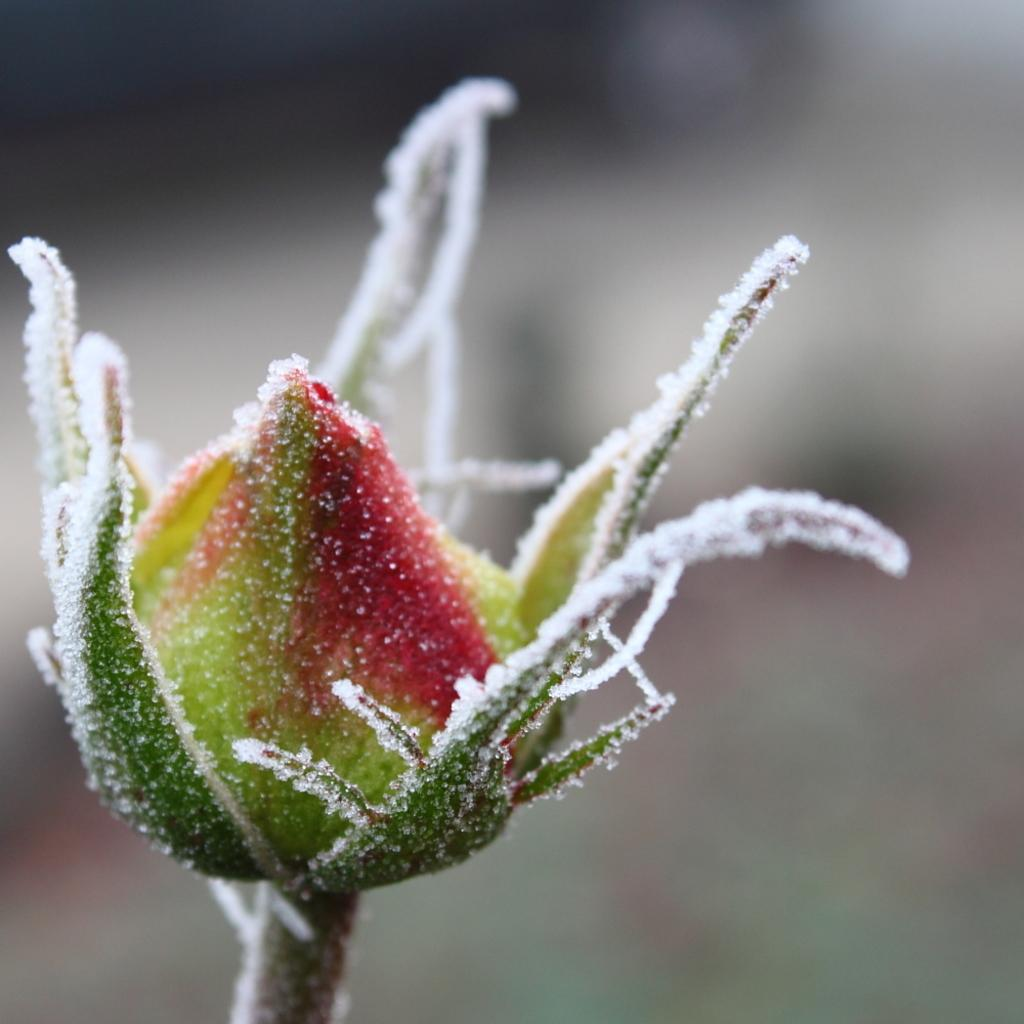What is the main subject of the image? The main subject of the image is a flower bud. Can you describe the condition of the flower bud? The flower bud has snow on it. What can be seen in the background of the image? The background of the image is not clear. How many cent sticks are used to hold up the houses in the image? There are no houses or cent sticks present in the image. 